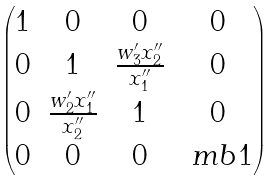<formula> <loc_0><loc_0><loc_500><loc_500>\begin{pmatrix} 1 & 0 & 0 & 0 \\ 0 & 1 & \frac { w _ { 3 } ^ { \prime } x _ { 2 } ^ { \prime \prime } } { x _ { 1 } ^ { \prime \prime } } & 0 \\ 0 & \frac { w _ { 2 } ^ { \prime } x _ { 1 } ^ { \prime \prime } } { x _ { 2 } ^ { \prime \prime } } & 1 & 0 \\ 0 & 0 & 0 & \ m b { 1 } \end{pmatrix}</formula> 